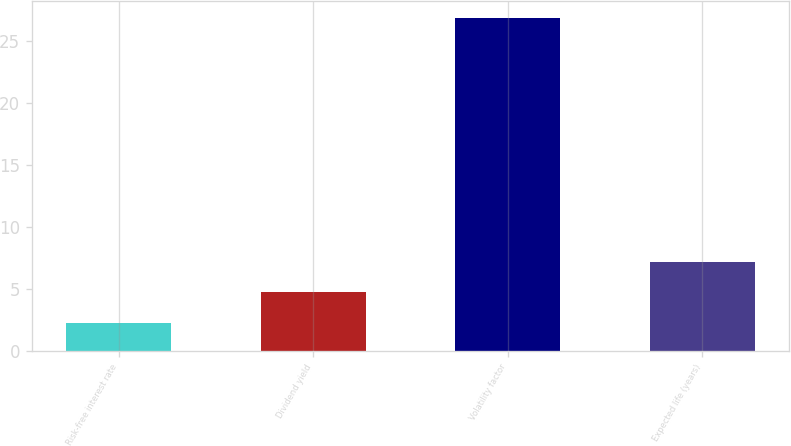<chart> <loc_0><loc_0><loc_500><loc_500><bar_chart><fcel>Risk-free interest rate<fcel>Dividend yield<fcel>Volatility factor<fcel>Expected life (years)<nl><fcel>2.28<fcel>4.74<fcel>26.91<fcel>7.22<nl></chart> 